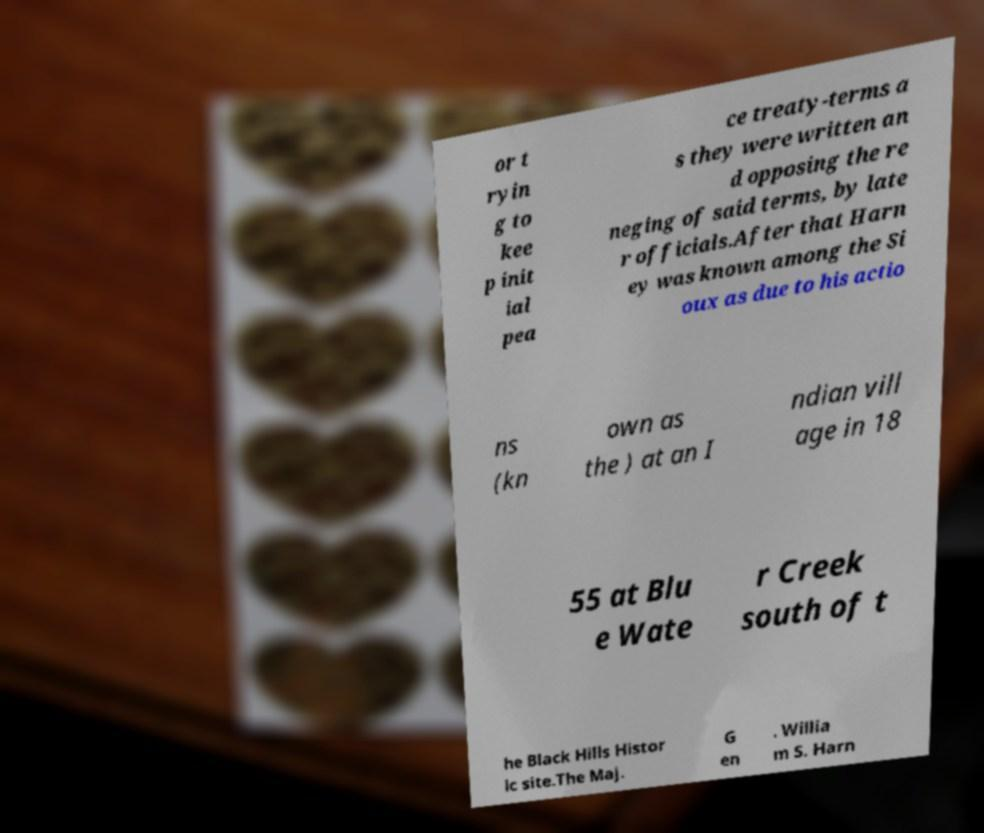Please read and relay the text visible in this image. What does it say? or t ryin g to kee p init ial pea ce treaty-terms a s they were written an d opposing the re neging of said terms, by late r officials.After that Harn ey was known among the Si oux as due to his actio ns (kn own as the ) at an I ndian vill age in 18 55 at Blu e Wate r Creek south of t he Black Hills Histor ic site.The Maj. G en . Willia m S. Harn 